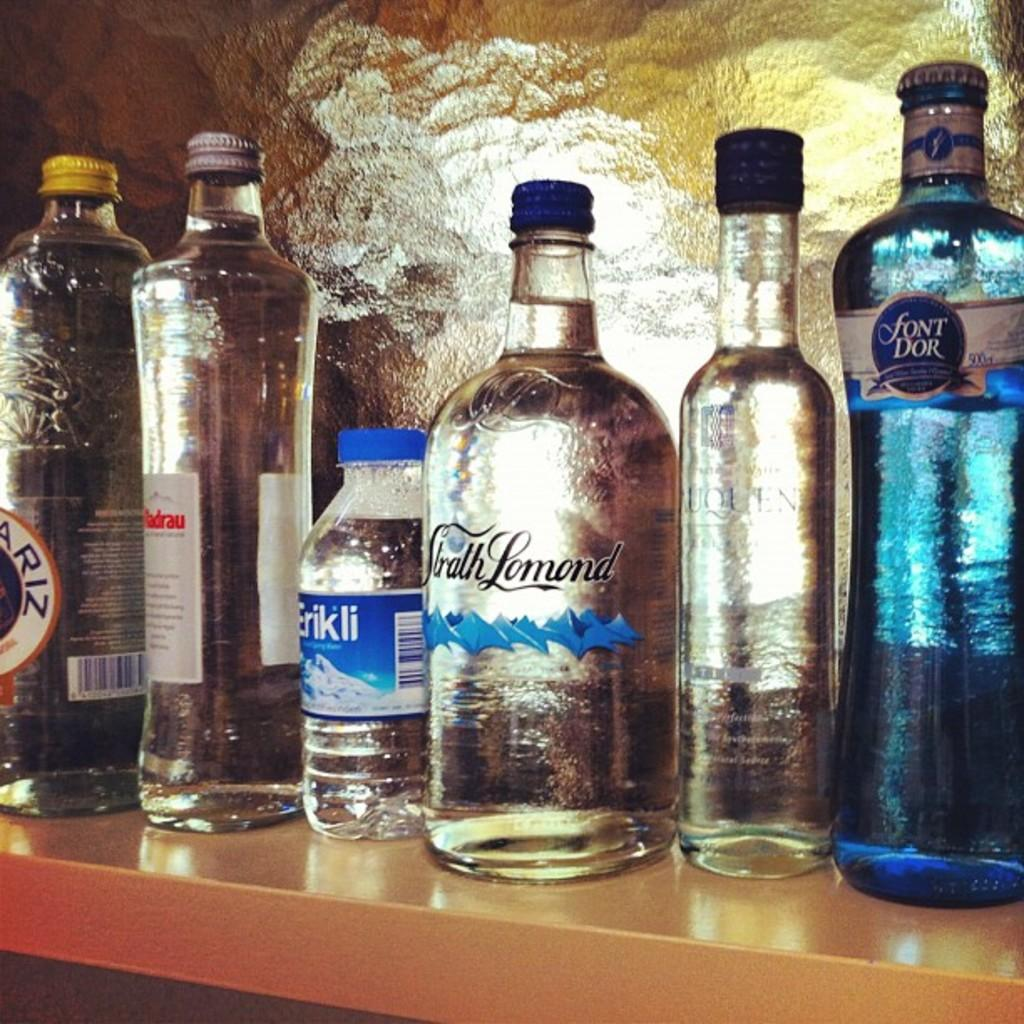<image>
Create a compact narrative representing the image presented. Many clear bottles sit on a wood shelf, including Font Dor. 